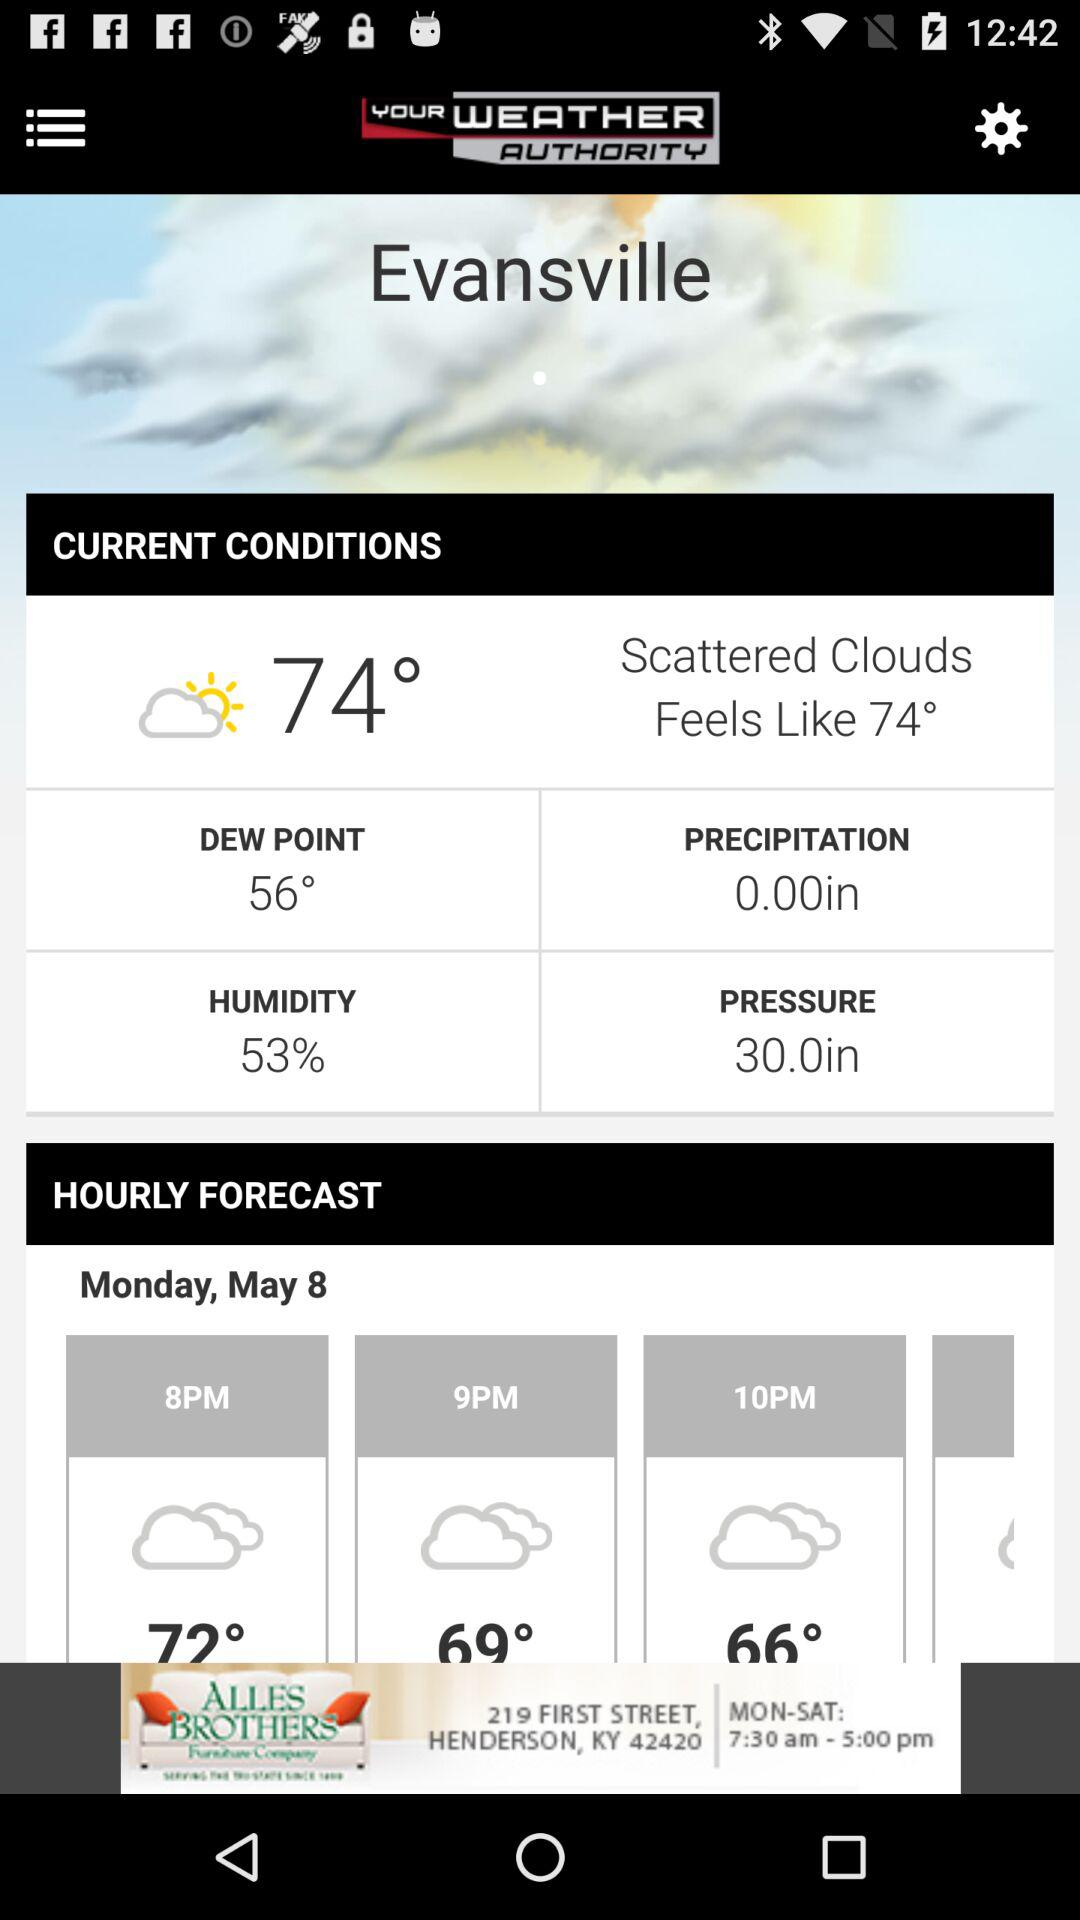What is the current humidity? The current humidity is 53%. 